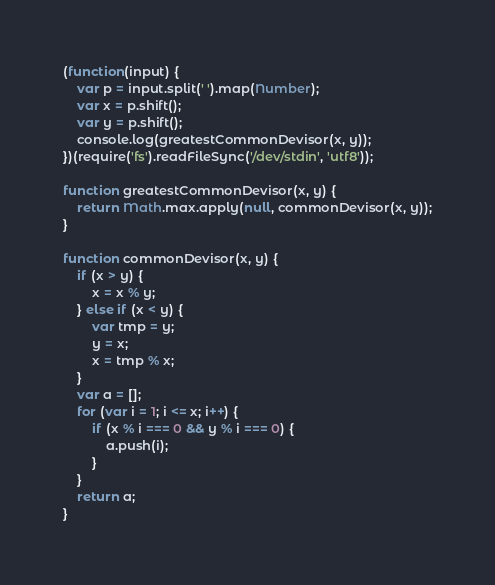Convert code to text. <code><loc_0><loc_0><loc_500><loc_500><_JavaScript_>(function(input) {
    var p = input.split(' ').map(Number);
    var x = p.shift();
    var y = p.shift();
    console.log(greatestCommonDevisor(x, y));
})(require('fs').readFileSync('/dev/stdin', 'utf8'));

function greatestCommonDevisor(x, y) {
    return Math.max.apply(null, commonDevisor(x, y));
}

function commonDevisor(x, y) {
    if (x > y) {
        x = x % y;
    } else if (x < y) {
        var tmp = y;
        y = x;
        x = tmp % x;
    }
    var a = [];
    for (var i = 1; i <= x; i++) {
        if (x % i === 0 && y % i === 0) {
            a.push(i);
        }
    }
    return a;
}</code> 